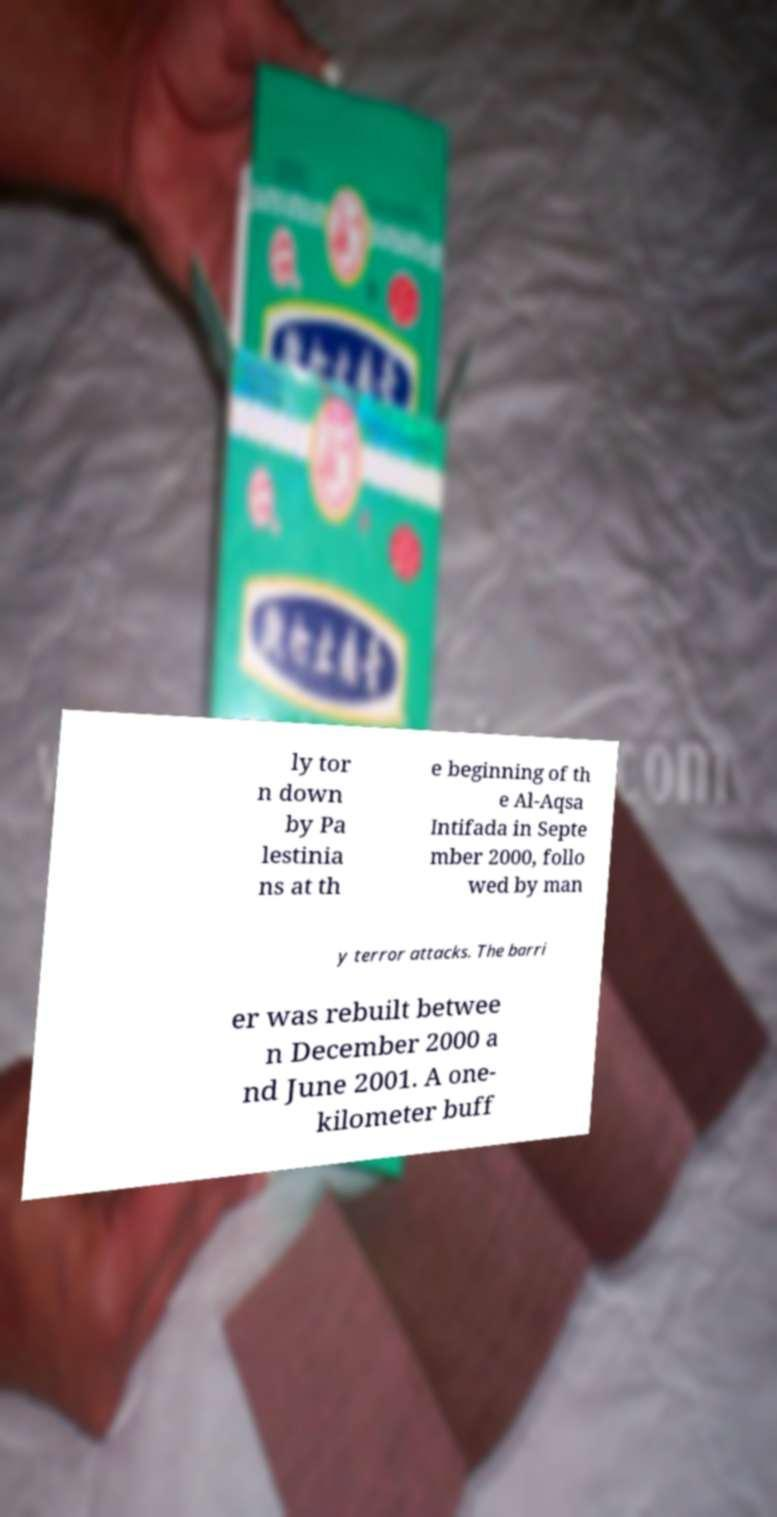Please identify and transcribe the text found in this image. ly tor n down by Pa lestinia ns at th e beginning of th e Al-Aqsa Intifada in Septe mber 2000, follo wed by man y terror attacks. The barri er was rebuilt betwee n December 2000 a nd June 2001. A one- kilometer buff 